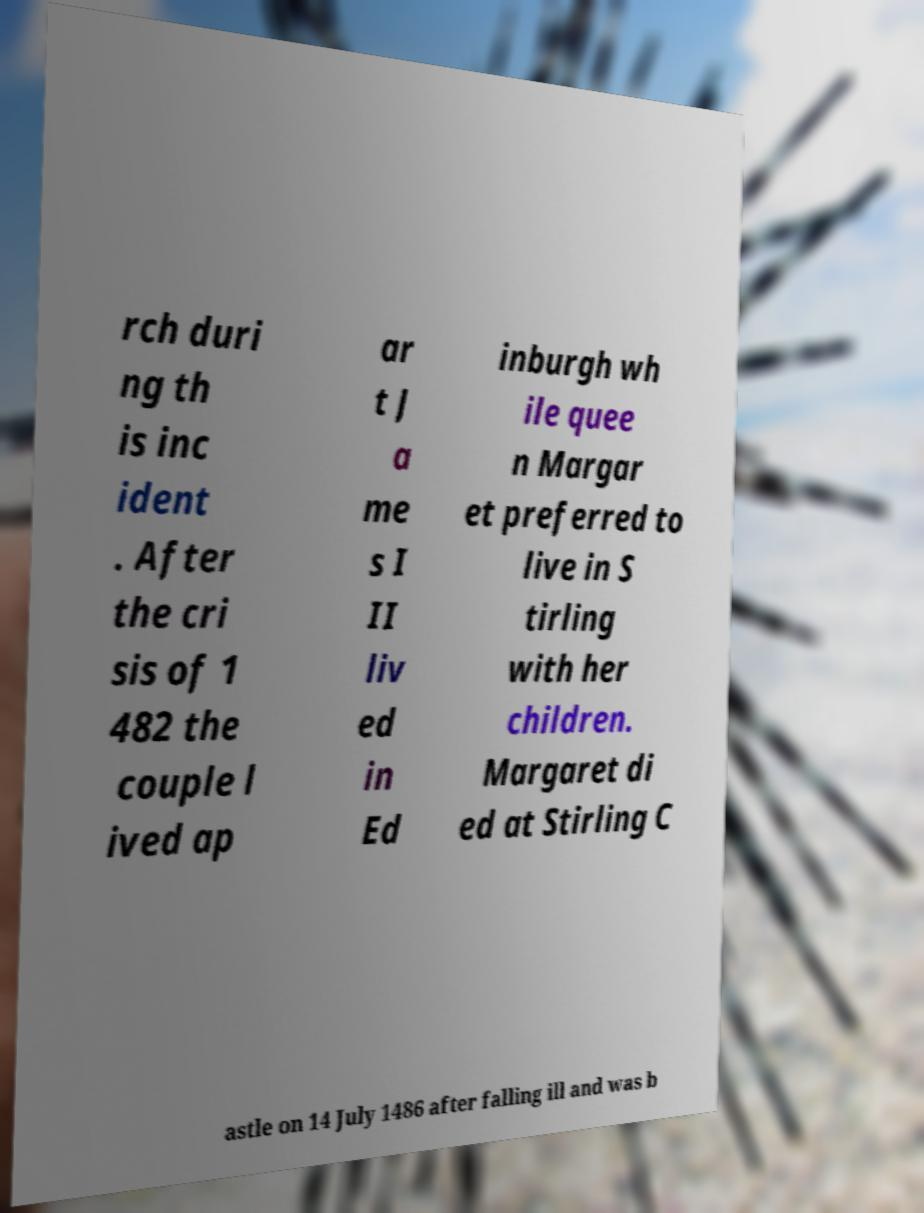For documentation purposes, I need the text within this image transcribed. Could you provide that? rch duri ng th is inc ident . After the cri sis of 1 482 the couple l ived ap ar t J a me s I II liv ed in Ed inburgh wh ile quee n Margar et preferred to live in S tirling with her children. Margaret di ed at Stirling C astle on 14 July 1486 after falling ill and was b 